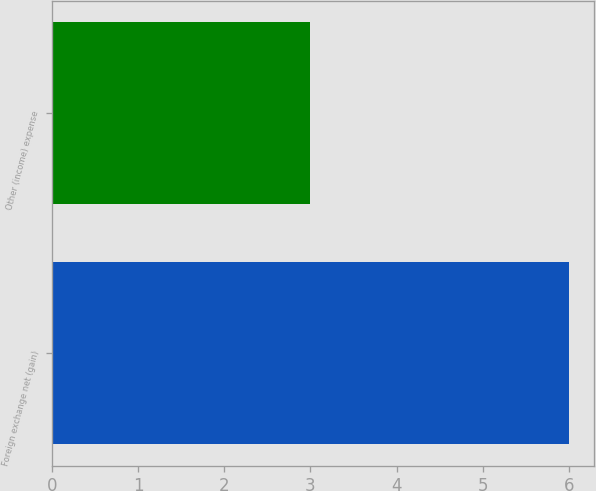Convert chart. <chart><loc_0><loc_0><loc_500><loc_500><bar_chart><fcel>Foreign exchange net (gain)<fcel>Other (income) expense<nl><fcel>6<fcel>3<nl></chart> 